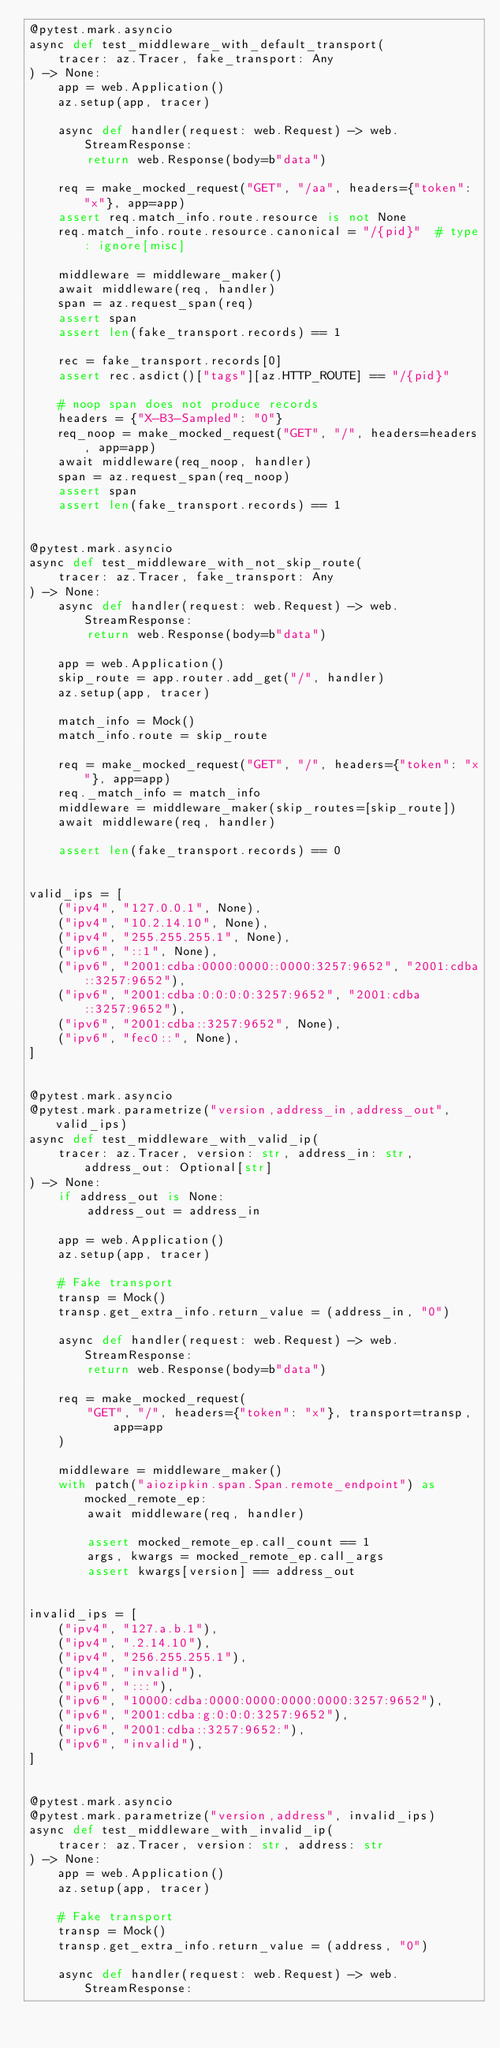Convert code to text. <code><loc_0><loc_0><loc_500><loc_500><_Python_>@pytest.mark.asyncio
async def test_middleware_with_default_transport(
    tracer: az.Tracer, fake_transport: Any
) -> None:
    app = web.Application()
    az.setup(app, tracer)

    async def handler(request: web.Request) -> web.StreamResponse:
        return web.Response(body=b"data")

    req = make_mocked_request("GET", "/aa", headers={"token": "x"}, app=app)
    assert req.match_info.route.resource is not None
    req.match_info.route.resource.canonical = "/{pid}"  # type: ignore[misc]

    middleware = middleware_maker()
    await middleware(req, handler)
    span = az.request_span(req)
    assert span
    assert len(fake_transport.records) == 1

    rec = fake_transport.records[0]
    assert rec.asdict()["tags"][az.HTTP_ROUTE] == "/{pid}"

    # noop span does not produce records
    headers = {"X-B3-Sampled": "0"}
    req_noop = make_mocked_request("GET", "/", headers=headers, app=app)
    await middleware(req_noop, handler)
    span = az.request_span(req_noop)
    assert span
    assert len(fake_transport.records) == 1


@pytest.mark.asyncio
async def test_middleware_with_not_skip_route(
    tracer: az.Tracer, fake_transport: Any
) -> None:
    async def handler(request: web.Request) -> web.StreamResponse:
        return web.Response(body=b"data")

    app = web.Application()
    skip_route = app.router.add_get("/", handler)
    az.setup(app, tracer)

    match_info = Mock()
    match_info.route = skip_route

    req = make_mocked_request("GET", "/", headers={"token": "x"}, app=app)
    req._match_info = match_info
    middleware = middleware_maker(skip_routes=[skip_route])
    await middleware(req, handler)

    assert len(fake_transport.records) == 0


valid_ips = [
    ("ipv4", "127.0.0.1", None),
    ("ipv4", "10.2.14.10", None),
    ("ipv4", "255.255.255.1", None),
    ("ipv6", "::1", None),
    ("ipv6", "2001:cdba:0000:0000::0000:3257:9652", "2001:cdba::3257:9652"),
    ("ipv6", "2001:cdba:0:0:0:0:3257:9652", "2001:cdba::3257:9652"),
    ("ipv6", "2001:cdba::3257:9652", None),
    ("ipv6", "fec0::", None),
]


@pytest.mark.asyncio
@pytest.mark.parametrize("version,address_in,address_out", valid_ips)
async def test_middleware_with_valid_ip(
    tracer: az.Tracer, version: str, address_in: str, address_out: Optional[str]
) -> None:
    if address_out is None:
        address_out = address_in

    app = web.Application()
    az.setup(app, tracer)

    # Fake transport
    transp = Mock()
    transp.get_extra_info.return_value = (address_in, "0")

    async def handler(request: web.Request) -> web.StreamResponse:
        return web.Response(body=b"data")

    req = make_mocked_request(
        "GET", "/", headers={"token": "x"}, transport=transp, app=app
    )

    middleware = middleware_maker()
    with patch("aiozipkin.span.Span.remote_endpoint") as mocked_remote_ep:
        await middleware(req, handler)

        assert mocked_remote_ep.call_count == 1
        args, kwargs = mocked_remote_ep.call_args
        assert kwargs[version] == address_out


invalid_ips = [
    ("ipv4", "127.a.b.1"),
    ("ipv4", ".2.14.10"),
    ("ipv4", "256.255.255.1"),
    ("ipv4", "invalid"),
    ("ipv6", ":::"),
    ("ipv6", "10000:cdba:0000:0000:0000:0000:3257:9652"),
    ("ipv6", "2001:cdba:g:0:0:0:3257:9652"),
    ("ipv6", "2001:cdba::3257:9652:"),
    ("ipv6", "invalid"),
]


@pytest.mark.asyncio
@pytest.mark.parametrize("version,address", invalid_ips)
async def test_middleware_with_invalid_ip(
    tracer: az.Tracer, version: str, address: str
) -> None:
    app = web.Application()
    az.setup(app, tracer)

    # Fake transport
    transp = Mock()
    transp.get_extra_info.return_value = (address, "0")

    async def handler(request: web.Request) -> web.StreamResponse:</code> 